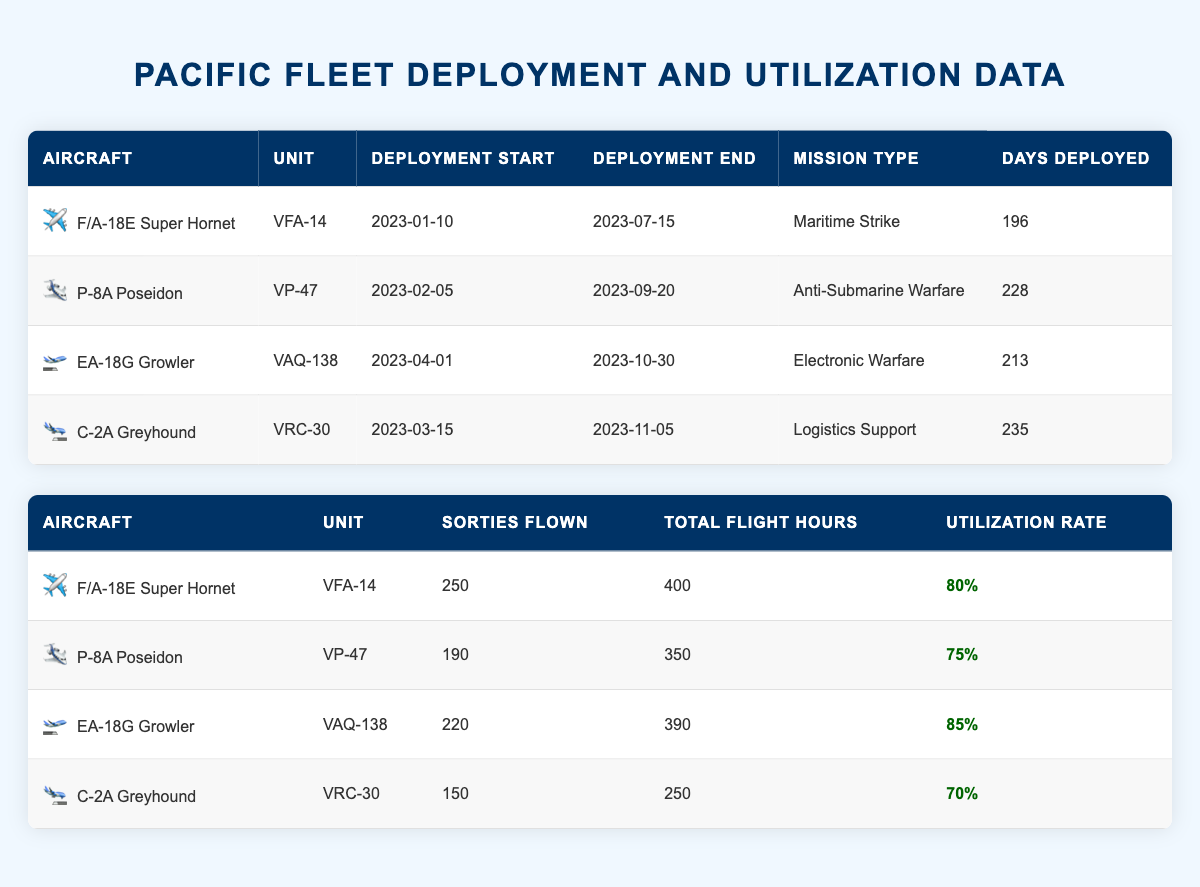What is the total number of days deployed for the C-2A Greyhound? The C-2A Greyhound has a value listed under "Days Deployed" in the deployment schedule, which is 235 days.
Answer: 235 Which aircraft has the highest utilization rate? The EA-18G Growler has the highest utilization rate at 85%, as seen in the utilization rates table.
Answer: EA-18G Growler Was the P-8A Poseidon deployed for more than 200 days? The number of days deployed for the P-8A Poseidon is 228, which is greater than 200 days.
Answer: Yes What is the average utilization rate of all aircraft? The utilization rates for all aircraft are 80%, 75%, 85%, and 70%. First, sum these rates: 80 + 75 + 85 + 70 = 310. Then divide by the number of aircraft (4): 310 / 4 = 77.5%.
Answer: 77.5% How many total sorties were flown by all the aircraft in the table? The total sorties flown are 250 + 190 + 220 + 150, which equals 810.
Answer: 810 Did the F/A-18E Super Hornet have a longer deployment than the P-8A Poseidon? The F/A-18E Super Hornet was deployed for 196 days, while the P-8A Poseidon was deployed for 228 days. Since 196 is less than 228, the F/A-18E did not have a longer deployment.
Answer: No What was the difference in total flight hours between the C-2A Greyhound and the EA-18G Growler? The total flight hours for the C-2A Greyhound is 250 hours and for the EA-18G Growler is 390 hours. The difference is 390 - 250 = 140 hours.
Answer: 140 Which unit was deployed for the electronic warfare mission? The unit that conducted the electronic warfare mission is VAQ-138, as specified in the deployment schedules table.
Answer: VAQ-138 